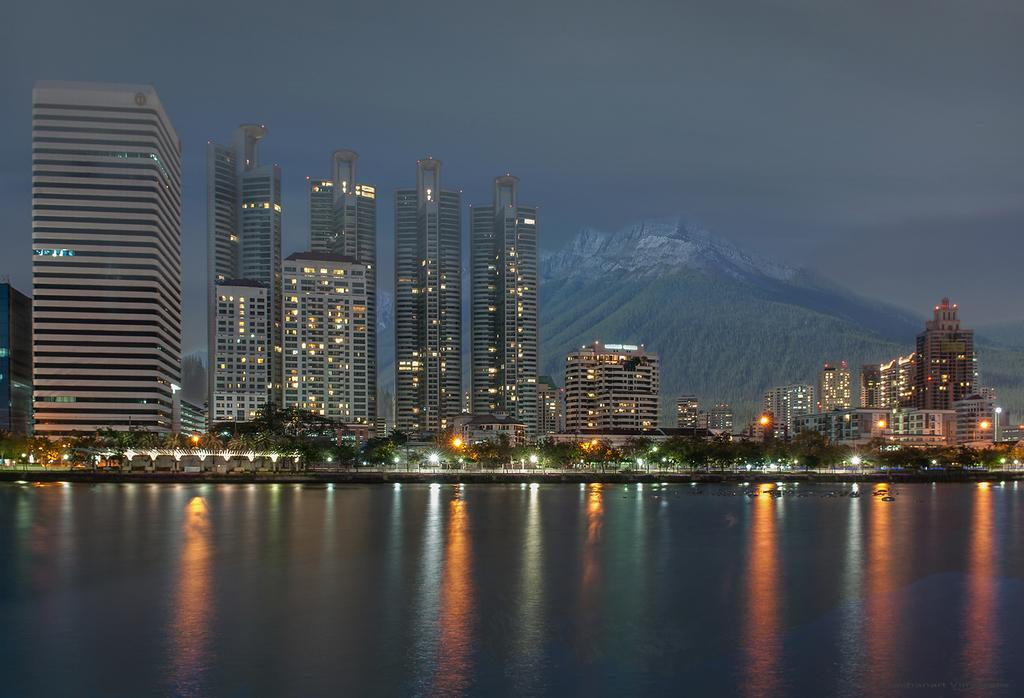What type of natural feature can be seen in the image? There is a river in the image. What type of man-made structures are present in the image? There are tall buildings in the image. What type of vegetation is visible in the image? There are trees in the image. What type of artificial light sources can be seen in the image? There are lights in the image. What type of geographical feature is visible in the background of the image? There are hills visible in the background of the image. What part of the natural environment is visible in the background of the image? The sky is visible in the background of the image. What type of pie is being served to the governor in the image? There is no governor or pie present in the image. Can you describe the bee's role in the image? There are no bees present in the image. 